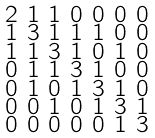<formula> <loc_0><loc_0><loc_500><loc_500>\begin{smallmatrix} 2 & 1 & 1 & 0 & 0 & 0 & 0 \\ 1 & 3 & 1 & 1 & 1 & 0 & 0 \\ 1 & 1 & 3 & 1 & 0 & 1 & 0 \\ 0 & 1 & 1 & 3 & 1 & 0 & 0 \\ 0 & 1 & 0 & 1 & 3 & 1 & 0 \\ 0 & 0 & 1 & 0 & 1 & 3 & 1 \\ 0 & 0 & 0 & 0 & 0 & 1 & 3 \end{smallmatrix}</formula> 